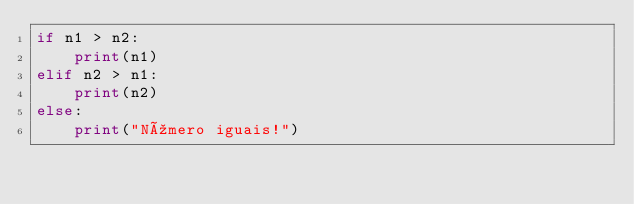Convert code to text. <code><loc_0><loc_0><loc_500><loc_500><_Python_>if n1 > n2:
    print(n1)
elif n2 > n1:
    print(n2)
else:
    print("Número iguais!")</code> 